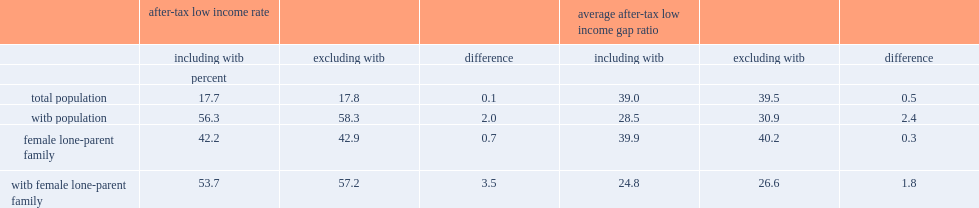Which popluation has a higher after-tax low-income rate compared to the total population? Witb population. Which population had a lower gap ratio compared to the total population? Witb population. What is the after-tax low-income rate for witb recipients? 56.3. What is the after-tax low-income rate for the total population? 17.7. What is the low-income gap ratio for witb population? 28.5. Excluding witb from income, what is the low-income rate for total population? 17.8. Excluding witb from income, what is the low-income rate for witb recipients? 58.3. According to the cflim-at, what is the low-income rate for persons in female lone-parent families? 42.2. Excluding the witb, what is the low-income rate for persons in female lone-parent families? 42.9. What is the low-income rates among witb receiving female headed lone parent families? 53.7. What is the low-income rates among witb receiving female headed lone parent families not including the witb benefits? 57.2. 